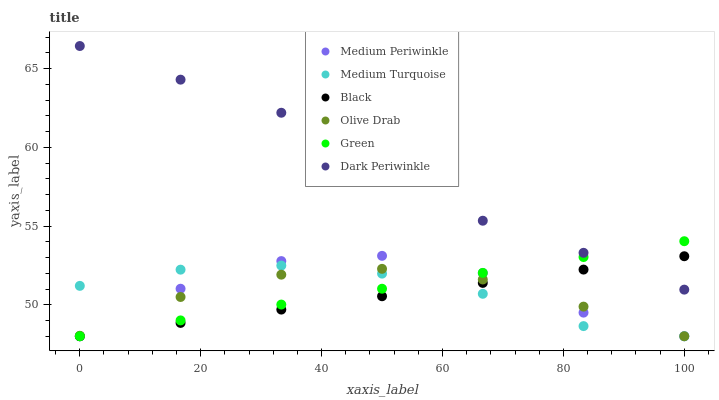Does Black have the minimum area under the curve?
Answer yes or no. Yes. Does Dark Periwinkle have the maximum area under the curve?
Answer yes or no. Yes. Does Medium Turquoise have the minimum area under the curve?
Answer yes or no. No. Does Medium Turquoise have the maximum area under the curve?
Answer yes or no. No. Is Black the smoothest?
Answer yes or no. Yes. Is Medium Periwinkle the roughest?
Answer yes or no. Yes. Is Medium Turquoise the smoothest?
Answer yes or no. No. Is Medium Turquoise the roughest?
Answer yes or no. No. Does Medium Periwinkle have the lowest value?
Answer yes or no. Yes. Does Dark Periwinkle have the lowest value?
Answer yes or no. No. Does Dark Periwinkle have the highest value?
Answer yes or no. Yes. Does Black have the highest value?
Answer yes or no. No. Is Medium Periwinkle less than Dark Periwinkle?
Answer yes or no. Yes. Is Dark Periwinkle greater than Medium Periwinkle?
Answer yes or no. Yes. Does Olive Drab intersect Black?
Answer yes or no. Yes. Is Olive Drab less than Black?
Answer yes or no. No. Is Olive Drab greater than Black?
Answer yes or no. No. Does Medium Periwinkle intersect Dark Periwinkle?
Answer yes or no. No. 